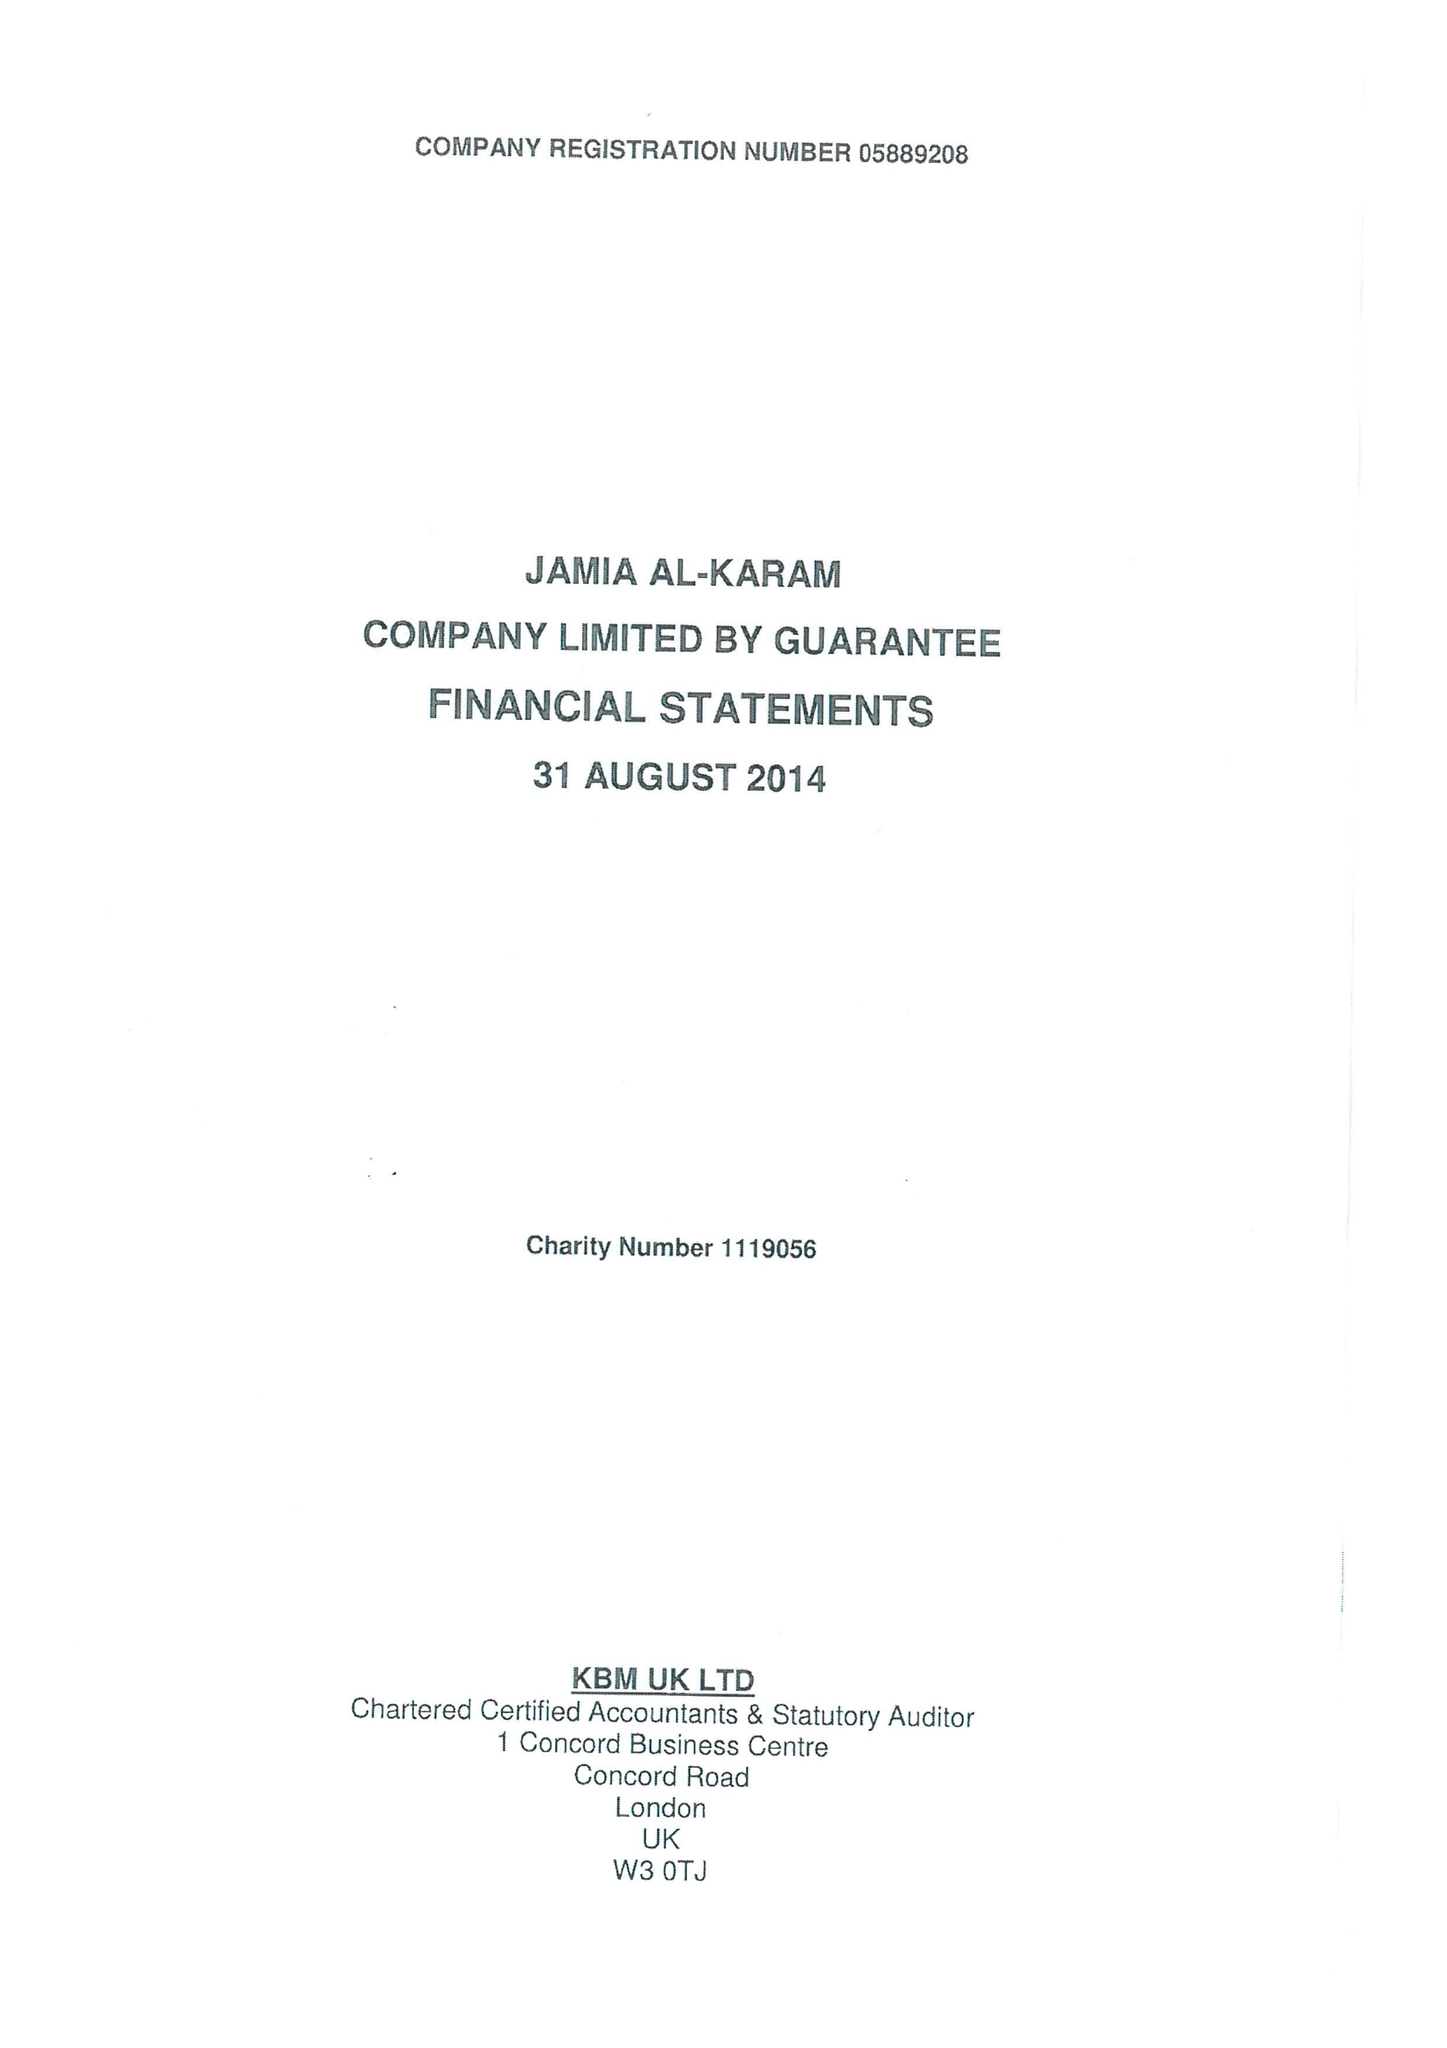What is the value for the address__street_line?
Answer the question using a single word or phrase. None 